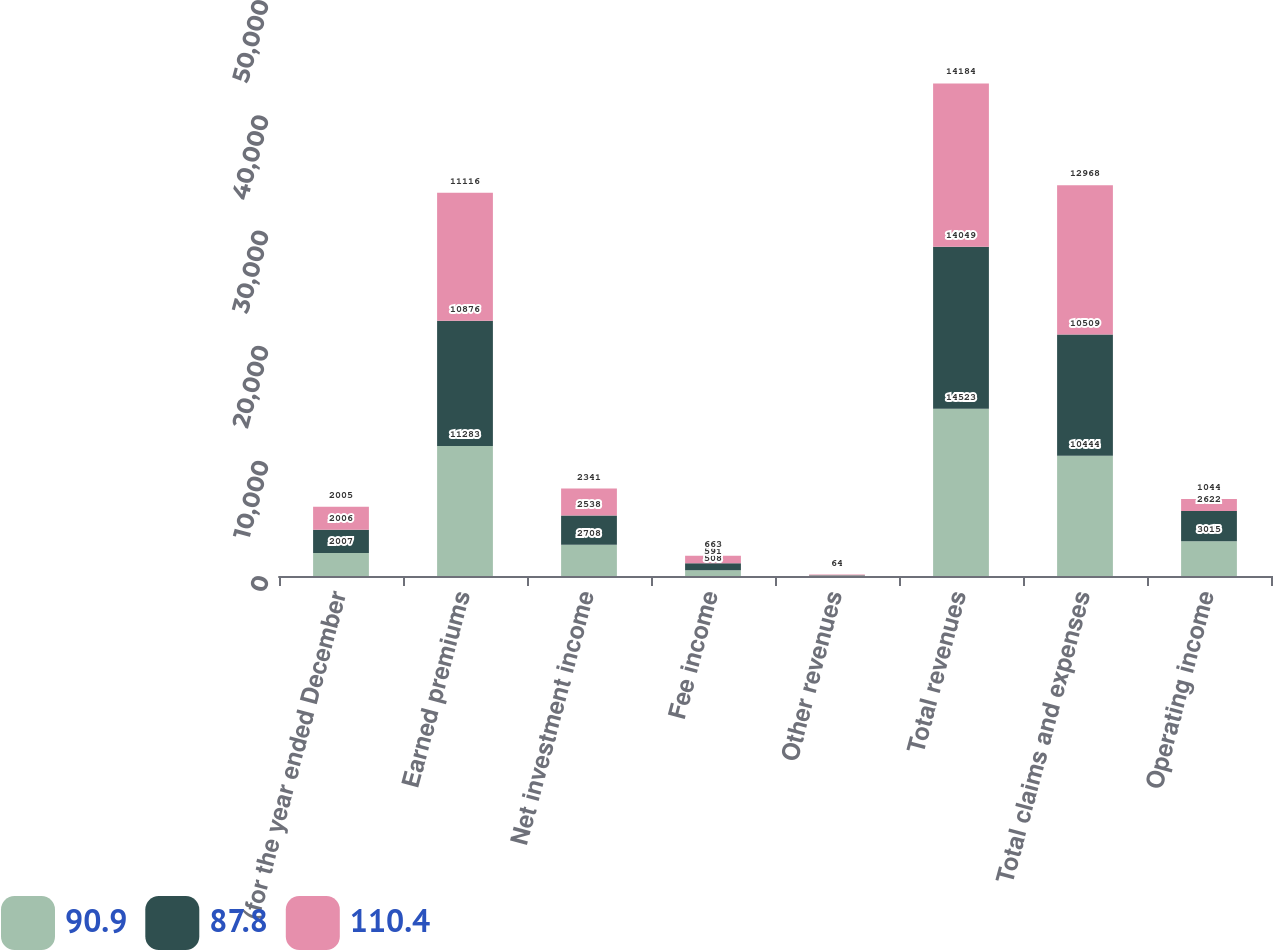Convert chart to OTSL. <chart><loc_0><loc_0><loc_500><loc_500><stacked_bar_chart><ecel><fcel>(for the year ended December<fcel>Earned premiums<fcel>Net investment income<fcel>Fee income<fcel>Other revenues<fcel>Total revenues<fcel>Total claims and expenses<fcel>Operating income<nl><fcel>90.9<fcel>2007<fcel>11283<fcel>2708<fcel>508<fcel>24<fcel>14523<fcel>10444<fcel>3015<nl><fcel>87.8<fcel>2006<fcel>10876<fcel>2538<fcel>591<fcel>44<fcel>14049<fcel>10509<fcel>2622<nl><fcel>110.4<fcel>2005<fcel>11116<fcel>2341<fcel>663<fcel>64<fcel>14184<fcel>12968<fcel>1044<nl></chart> 